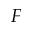Convert formula to latex. <formula><loc_0><loc_0><loc_500><loc_500>F</formula> 